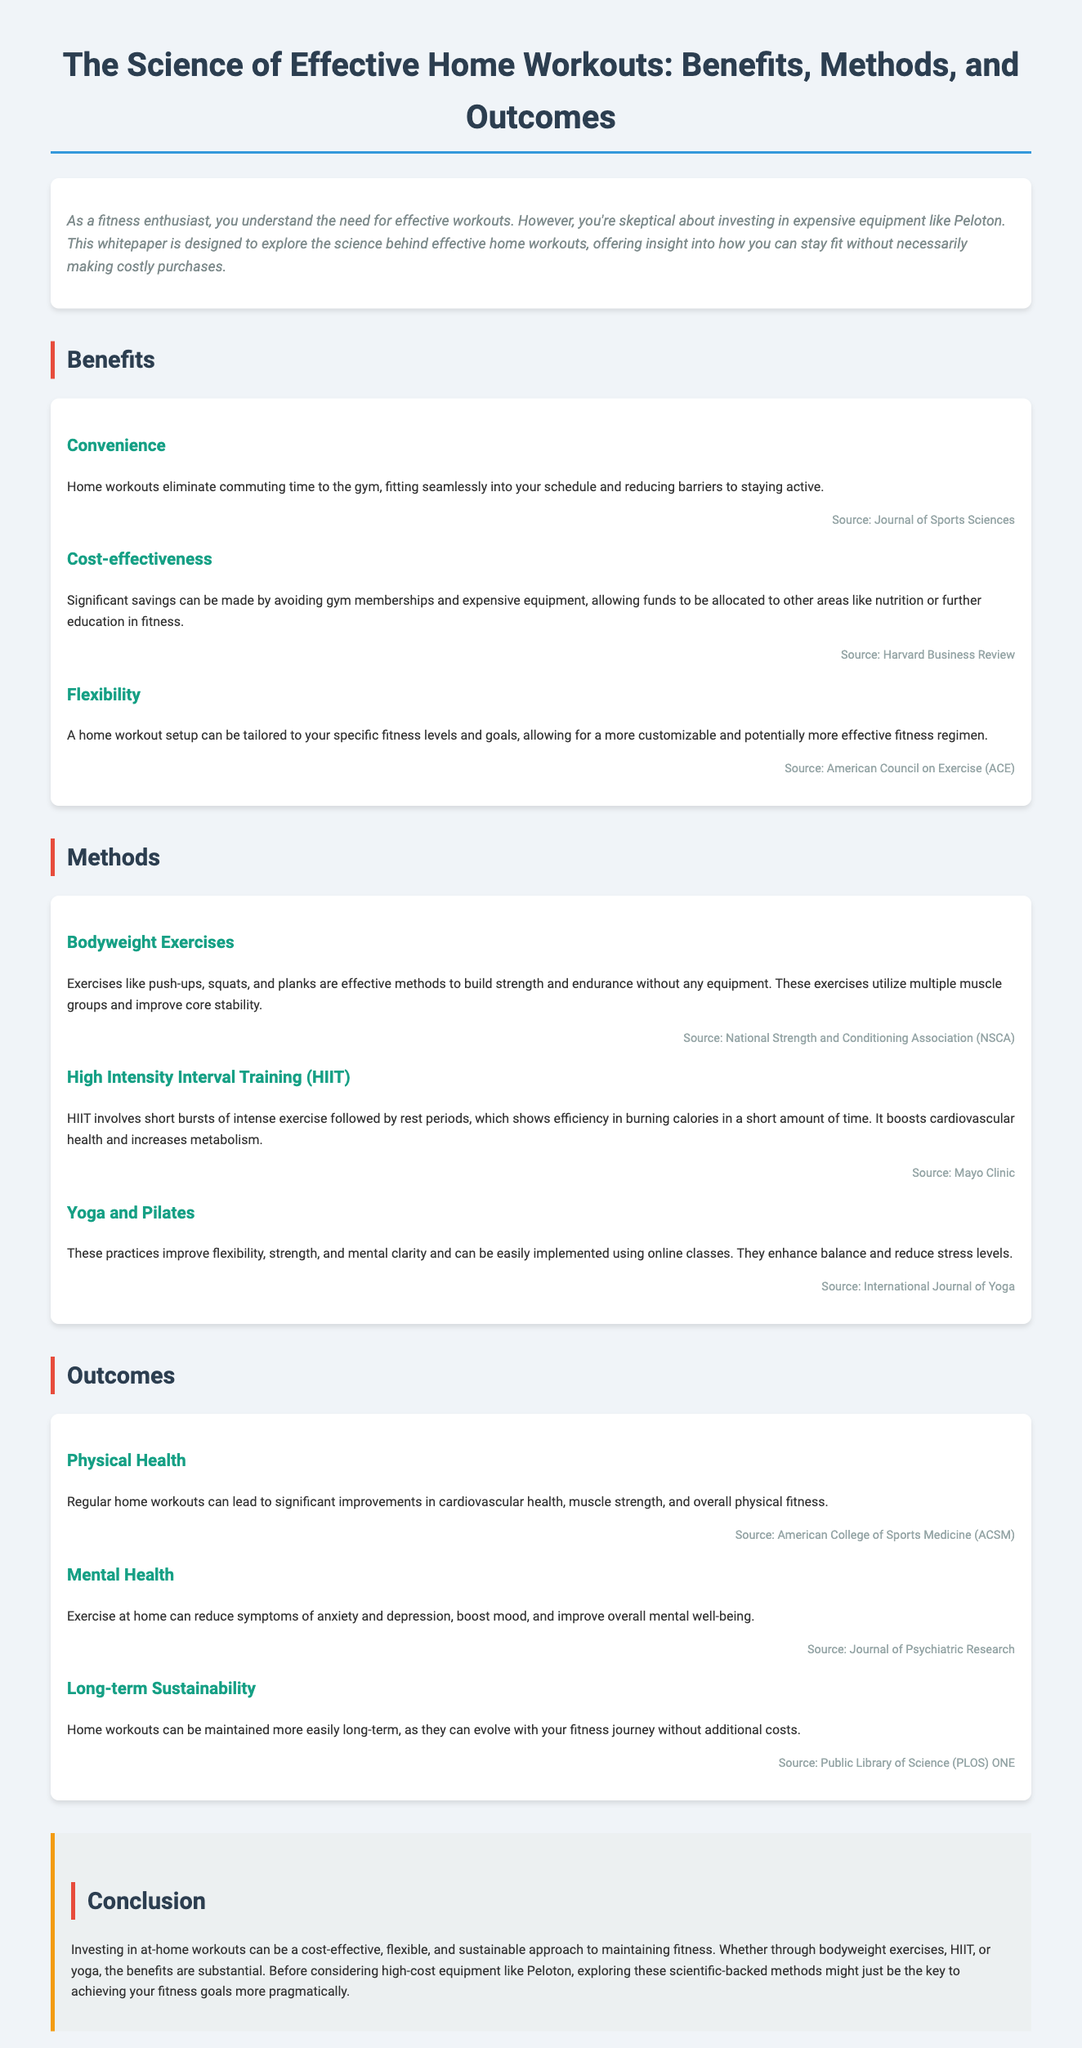What are two benefits of home workouts mentioned? The document lists convenience and cost-effectiveness as benefits of home workouts.
Answer: convenience, cost-effectiveness What type of exercise is emphasized for strength without equipment? Bodyweight exercises like push-ups, squats, and planks are mentioned as effective for building strength.
Answer: Bodyweight exercises Which training method is highlighted for burning calories efficiently? High Intensity Interval Training (HIIT) is noted for its efficiency in burning calories quickly.
Answer: HIIT What impact do home workouts have on mental health? The document states that exercise at home reduces symptoms of anxiety and depression, boosting mood.
Answer: reduces symptoms of anxiety and depression What is a customizable aspect of home workouts? Home workout setups can be tailored to specific fitness levels and goals, allowing more customization.
Answer: customizable to specific fitness levels and goals Which organization published findings on physical health outcomes from home workouts? The American College of Sports Medicine (ACSM) is cited for improvements in physical health from regular home workouts.
Answer: American College of Sports Medicine (ACSM) What does the conclusion suggest regarding high-cost equipment like Peloton? The conclusion suggests exploring scientific-backed methods before considering high-cost equipment.
Answer: exploring scientific-backed methods Which practice improves flexibility and mental clarity? Yoga and Pilates are mentioned as practices that enhance flexibility, strength, and mental clarity.
Answer: Yoga and Pilates 